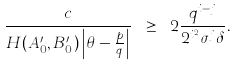<formula> <loc_0><loc_0><loc_500><loc_500>\frac { c } { H ( A ^ { \prime } _ { 0 } , B ^ { \prime } _ { 0 } ) \left | \theta - \frac { p } { q } \right | } \ \geq \ 2 \frac { q ^ { i - j } } { 2 ^ { i ^ { 2 } } \sigma ^ { j } \delta } .</formula> 